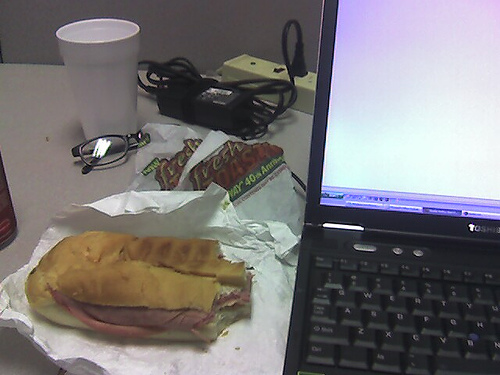How many laptops can be seen? There is one laptop visible in the image, situated on a desk next to a sandwich and a drink, with its screen turned on showing a blank or white screen. 